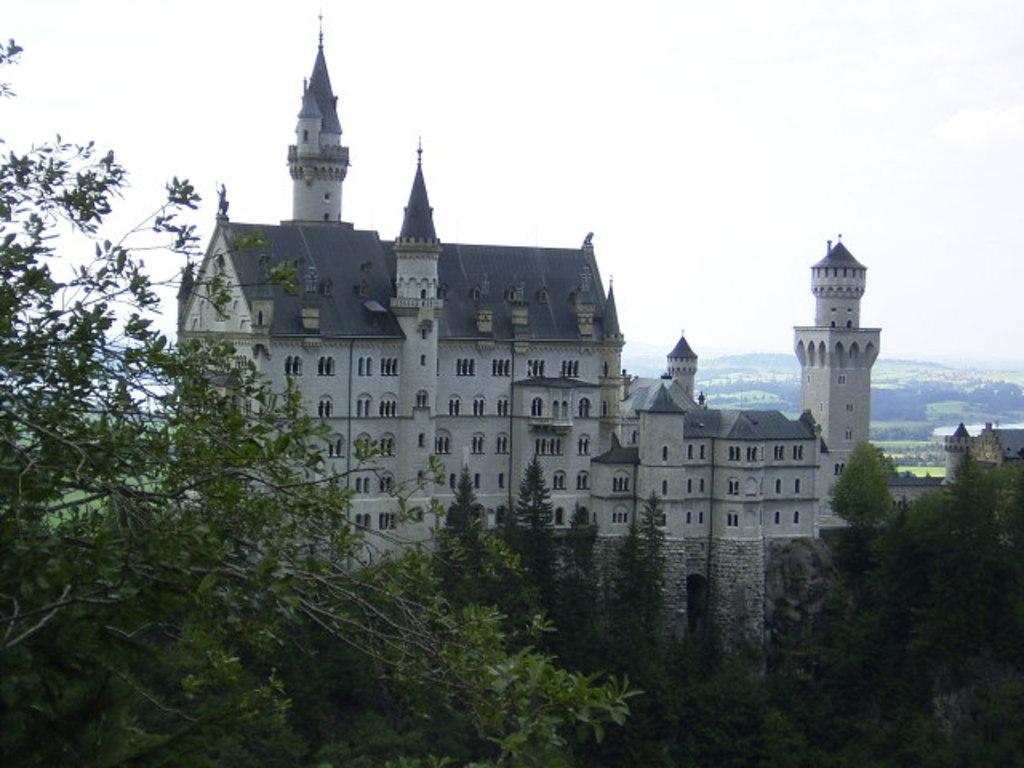How would you summarize this image in a sentence or two? In the given image i can see a castle,trees,plants,mountains and in the background i can see the sky. 